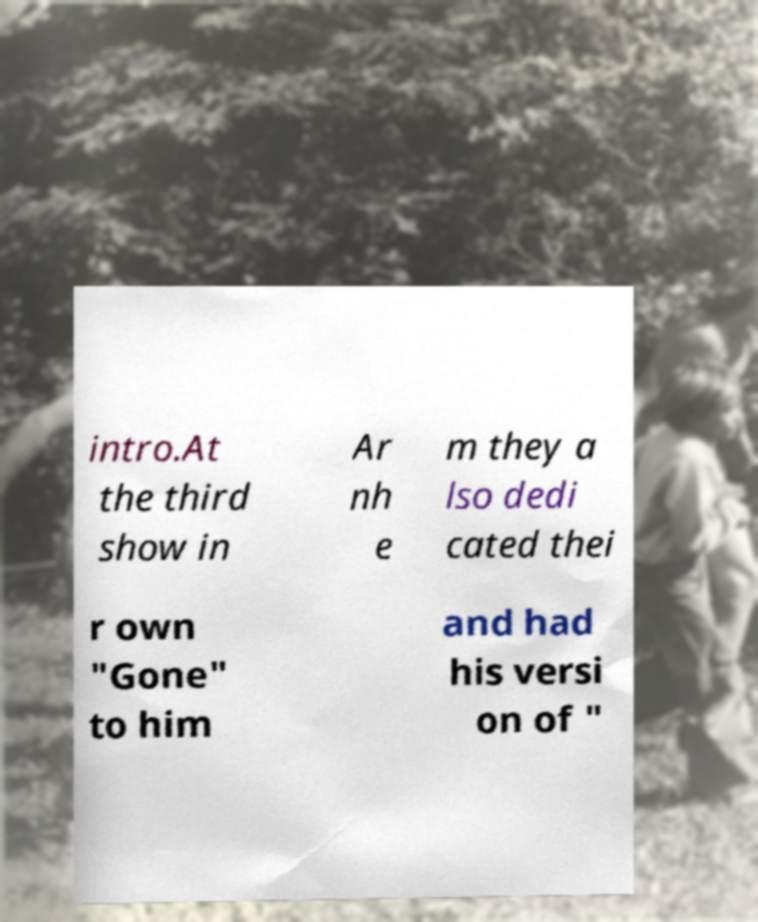Could you assist in decoding the text presented in this image and type it out clearly? intro.At the third show in Ar nh e m they a lso dedi cated thei r own "Gone" to him and had his versi on of " 